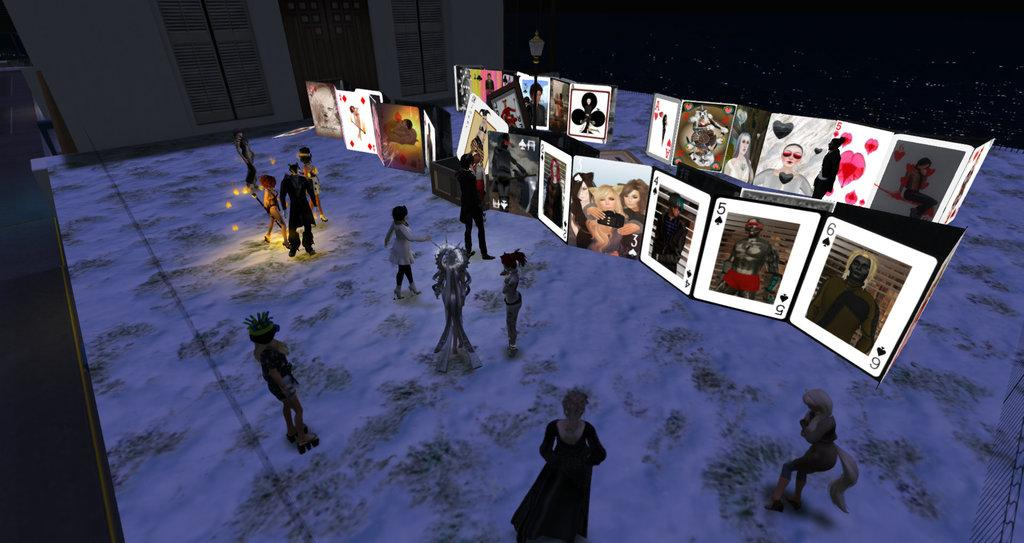What type of image is being described? The image is an animation. What objects can be seen in the image? There are cards and toys in the image. What can be seen in the background of the image? There are lights, doors, a wall, and a pole in the background of the image. How much income does the owl generate in the image? There is no owl present in the image, so it is not possible to determine its income. 